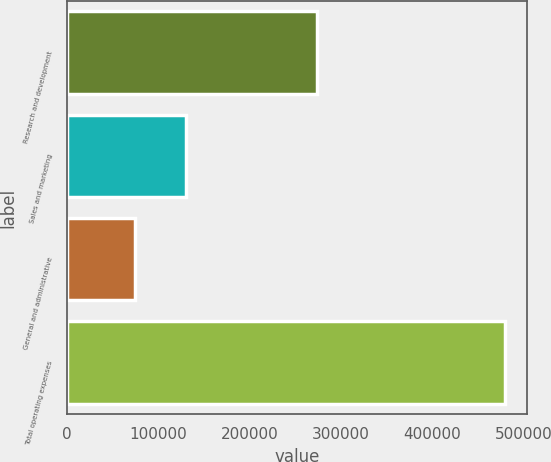Convert chart. <chart><loc_0><loc_0><loc_500><loc_500><bar_chart><fcel>Research and development<fcel>Sales and marketing<fcel>General and administrative<fcel>Total operating expenses<nl><fcel>273581<fcel>130887<fcel>75239<fcel>479707<nl></chart> 